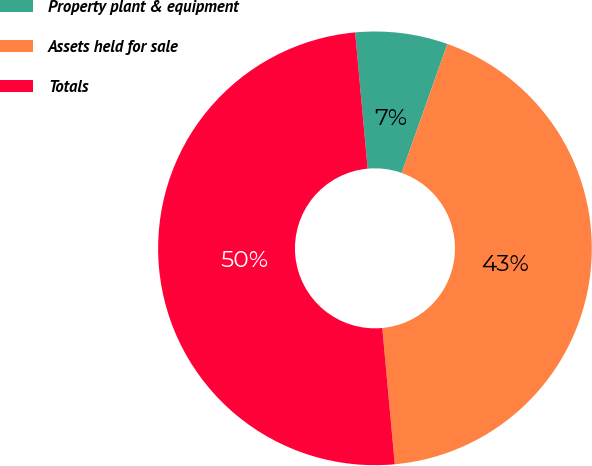Convert chart to OTSL. <chart><loc_0><loc_0><loc_500><loc_500><pie_chart><fcel>Property plant & equipment<fcel>Assets held for sale<fcel>Totals<nl><fcel>6.88%<fcel>43.12%<fcel>50.0%<nl></chart> 